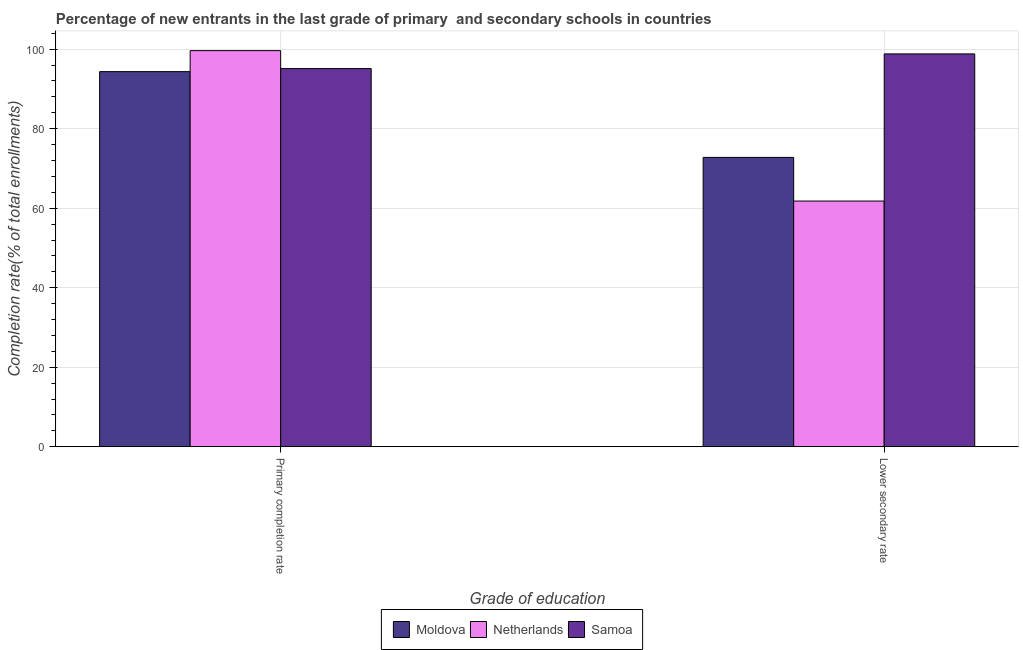How many groups of bars are there?
Your answer should be compact. 2. Are the number of bars per tick equal to the number of legend labels?
Offer a very short reply. Yes. How many bars are there on the 2nd tick from the left?
Your answer should be compact. 3. What is the label of the 2nd group of bars from the left?
Keep it short and to the point. Lower secondary rate. What is the completion rate in primary schools in Moldova?
Ensure brevity in your answer.  94.36. Across all countries, what is the maximum completion rate in primary schools?
Give a very brief answer. 99.64. Across all countries, what is the minimum completion rate in secondary schools?
Offer a very short reply. 61.8. In which country was the completion rate in primary schools minimum?
Keep it short and to the point. Moldova. What is the total completion rate in secondary schools in the graph?
Ensure brevity in your answer.  233.39. What is the difference between the completion rate in secondary schools in Netherlands and that in Samoa?
Keep it short and to the point. -37.02. What is the difference between the completion rate in secondary schools in Samoa and the completion rate in primary schools in Netherlands?
Ensure brevity in your answer.  -0.82. What is the average completion rate in primary schools per country?
Your answer should be very brief. 96.37. What is the difference between the completion rate in secondary schools and completion rate in primary schools in Moldova?
Offer a terse response. -21.58. What is the ratio of the completion rate in secondary schools in Samoa to that in Moldova?
Offer a very short reply. 1.36. What does the 3rd bar from the left in Lower secondary rate represents?
Offer a very short reply. Samoa. What does the 1st bar from the right in Primary completion rate represents?
Make the answer very short. Samoa. How many bars are there?
Offer a very short reply. 6. How many countries are there in the graph?
Give a very brief answer. 3. What is the difference between two consecutive major ticks on the Y-axis?
Offer a terse response. 20. How many legend labels are there?
Offer a terse response. 3. How are the legend labels stacked?
Provide a short and direct response. Horizontal. What is the title of the graph?
Keep it short and to the point. Percentage of new entrants in the last grade of primary  and secondary schools in countries. Does "Niger" appear as one of the legend labels in the graph?
Make the answer very short. No. What is the label or title of the X-axis?
Your answer should be very brief. Grade of education. What is the label or title of the Y-axis?
Keep it short and to the point. Completion rate(% of total enrollments). What is the Completion rate(% of total enrollments) of Moldova in Primary completion rate?
Provide a short and direct response. 94.36. What is the Completion rate(% of total enrollments) in Netherlands in Primary completion rate?
Give a very brief answer. 99.64. What is the Completion rate(% of total enrollments) in Samoa in Primary completion rate?
Make the answer very short. 95.12. What is the Completion rate(% of total enrollments) of Moldova in Lower secondary rate?
Offer a very short reply. 72.78. What is the Completion rate(% of total enrollments) in Netherlands in Lower secondary rate?
Offer a terse response. 61.8. What is the Completion rate(% of total enrollments) in Samoa in Lower secondary rate?
Give a very brief answer. 98.81. Across all Grade of education, what is the maximum Completion rate(% of total enrollments) in Moldova?
Your answer should be very brief. 94.36. Across all Grade of education, what is the maximum Completion rate(% of total enrollments) in Netherlands?
Your answer should be compact. 99.64. Across all Grade of education, what is the maximum Completion rate(% of total enrollments) in Samoa?
Make the answer very short. 98.81. Across all Grade of education, what is the minimum Completion rate(% of total enrollments) of Moldova?
Offer a terse response. 72.78. Across all Grade of education, what is the minimum Completion rate(% of total enrollments) of Netherlands?
Ensure brevity in your answer.  61.8. Across all Grade of education, what is the minimum Completion rate(% of total enrollments) of Samoa?
Provide a succinct answer. 95.12. What is the total Completion rate(% of total enrollments) of Moldova in the graph?
Offer a very short reply. 167.14. What is the total Completion rate(% of total enrollments) of Netherlands in the graph?
Your response must be concise. 161.44. What is the total Completion rate(% of total enrollments) in Samoa in the graph?
Provide a short and direct response. 193.94. What is the difference between the Completion rate(% of total enrollments) in Moldova in Primary completion rate and that in Lower secondary rate?
Offer a very short reply. 21.58. What is the difference between the Completion rate(% of total enrollments) in Netherlands in Primary completion rate and that in Lower secondary rate?
Make the answer very short. 37.84. What is the difference between the Completion rate(% of total enrollments) in Samoa in Primary completion rate and that in Lower secondary rate?
Provide a succinct answer. -3.69. What is the difference between the Completion rate(% of total enrollments) of Moldova in Primary completion rate and the Completion rate(% of total enrollments) of Netherlands in Lower secondary rate?
Give a very brief answer. 32.56. What is the difference between the Completion rate(% of total enrollments) in Moldova in Primary completion rate and the Completion rate(% of total enrollments) in Samoa in Lower secondary rate?
Keep it short and to the point. -4.46. What is the difference between the Completion rate(% of total enrollments) in Netherlands in Primary completion rate and the Completion rate(% of total enrollments) in Samoa in Lower secondary rate?
Provide a short and direct response. 0.82. What is the average Completion rate(% of total enrollments) in Moldova per Grade of education?
Offer a very short reply. 83.57. What is the average Completion rate(% of total enrollments) in Netherlands per Grade of education?
Your answer should be compact. 80.72. What is the average Completion rate(% of total enrollments) in Samoa per Grade of education?
Your answer should be compact. 96.97. What is the difference between the Completion rate(% of total enrollments) in Moldova and Completion rate(% of total enrollments) in Netherlands in Primary completion rate?
Provide a succinct answer. -5.28. What is the difference between the Completion rate(% of total enrollments) of Moldova and Completion rate(% of total enrollments) of Samoa in Primary completion rate?
Give a very brief answer. -0.77. What is the difference between the Completion rate(% of total enrollments) in Netherlands and Completion rate(% of total enrollments) in Samoa in Primary completion rate?
Make the answer very short. 4.52. What is the difference between the Completion rate(% of total enrollments) of Moldova and Completion rate(% of total enrollments) of Netherlands in Lower secondary rate?
Provide a short and direct response. 10.98. What is the difference between the Completion rate(% of total enrollments) in Moldova and Completion rate(% of total enrollments) in Samoa in Lower secondary rate?
Give a very brief answer. -26.04. What is the difference between the Completion rate(% of total enrollments) in Netherlands and Completion rate(% of total enrollments) in Samoa in Lower secondary rate?
Give a very brief answer. -37.02. What is the ratio of the Completion rate(% of total enrollments) of Moldova in Primary completion rate to that in Lower secondary rate?
Make the answer very short. 1.3. What is the ratio of the Completion rate(% of total enrollments) in Netherlands in Primary completion rate to that in Lower secondary rate?
Ensure brevity in your answer.  1.61. What is the ratio of the Completion rate(% of total enrollments) of Samoa in Primary completion rate to that in Lower secondary rate?
Your response must be concise. 0.96. What is the difference between the highest and the second highest Completion rate(% of total enrollments) of Moldova?
Provide a short and direct response. 21.58. What is the difference between the highest and the second highest Completion rate(% of total enrollments) of Netherlands?
Keep it short and to the point. 37.84. What is the difference between the highest and the second highest Completion rate(% of total enrollments) in Samoa?
Ensure brevity in your answer.  3.69. What is the difference between the highest and the lowest Completion rate(% of total enrollments) of Moldova?
Offer a terse response. 21.58. What is the difference between the highest and the lowest Completion rate(% of total enrollments) in Netherlands?
Provide a short and direct response. 37.84. What is the difference between the highest and the lowest Completion rate(% of total enrollments) of Samoa?
Provide a short and direct response. 3.69. 